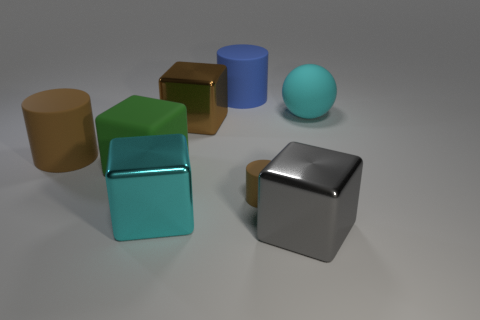What number of other things are the same material as the green thing?
Make the answer very short. 4. What number of large cylinders are to the left of the matte block that is to the left of the cyan thing in front of the matte cube?
Keep it short and to the point. 1. What number of metallic things are either cyan objects or green cubes?
Make the answer very short. 1. What is the size of the brown rubber object right of the big brown thing that is to the left of the big cyan shiny thing?
Keep it short and to the point. Small. There is a big shiny thing that is to the right of the blue rubber cylinder; does it have the same color as the large metal object that is behind the tiny thing?
Your response must be concise. No. The large thing that is both right of the tiny cylinder and on the left side of the large matte sphere is what color?
Provide a succinct answer. Gray. Are the big green block and the big brown cylinder made of the same material?
Ensure brevity in your answer.  Yes. What number of big things are either blue rubber cylinders or red matte balls?
Your response must be concise. 1. Is there any other thing that is the same shape as the blue rubber object?
Offer a very short reply. Yes. Is there any other thing that is the same size as the brown cube?
Ensure brevity in your answer.  Yes. 